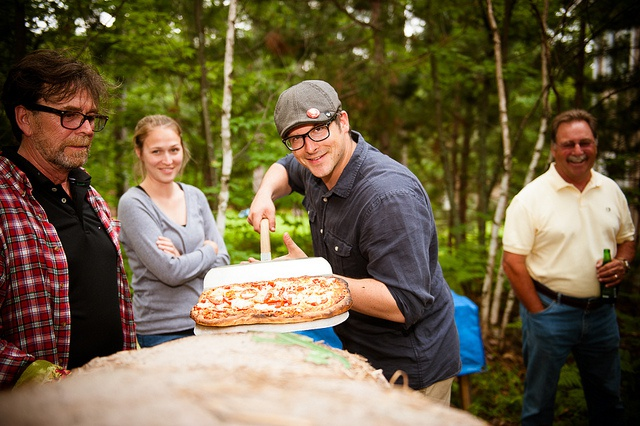Describe the objects in this image and their specific colors. I can see people in black, maroon, brown, and olive tones, people in black, gray, darkgray, and olive tones, people in black, beige, tan, and maroon tones, people in black, lightgray, darkgray, gray, and tan tones, and pizza in black, ivory, tan, and orange tones in this image. 